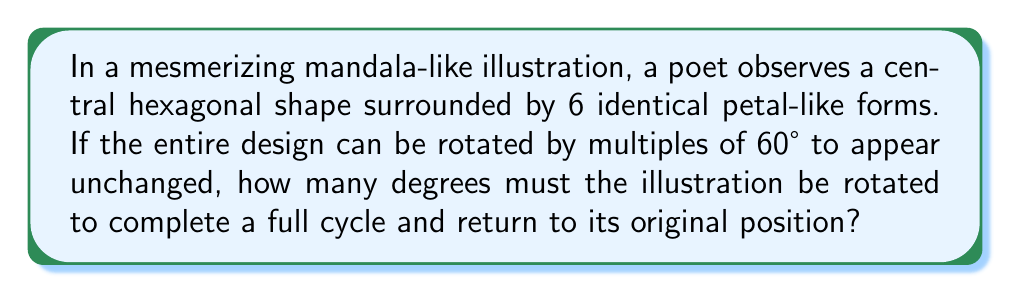Show me your answer to this math problem. Let's approach this step-by-step:

1) First, we need to understand the concept of rotational symmetry. An object has rotational symmetry if it looks the same after a certain amount of rotation.

2) In this case, the illustration can be rotated by multiples of 60° and appear unchanged. This means it has 6-fold rotational symmetry.

3) To calculate the number of degrees needed for a full cycle, we use the formula:

   $$\text{Full cycle} = \frac{360°}{\text{Number of symmetries}}$$

4) We know there are 6 symmetries (as it can be rotated by multiples of 60°):

   $$\text{Full cycle} = \frac{360°}{6}$$

5) Calculating:

   $$\text{Full cycle} = 60°$$

6) This makes sense, as 60° is the smallest rotation that makes the illustration appear unchanged. After 6 of these rotations (6 × 60° = 360°), we complete a full cycle.
Answer: 360° 